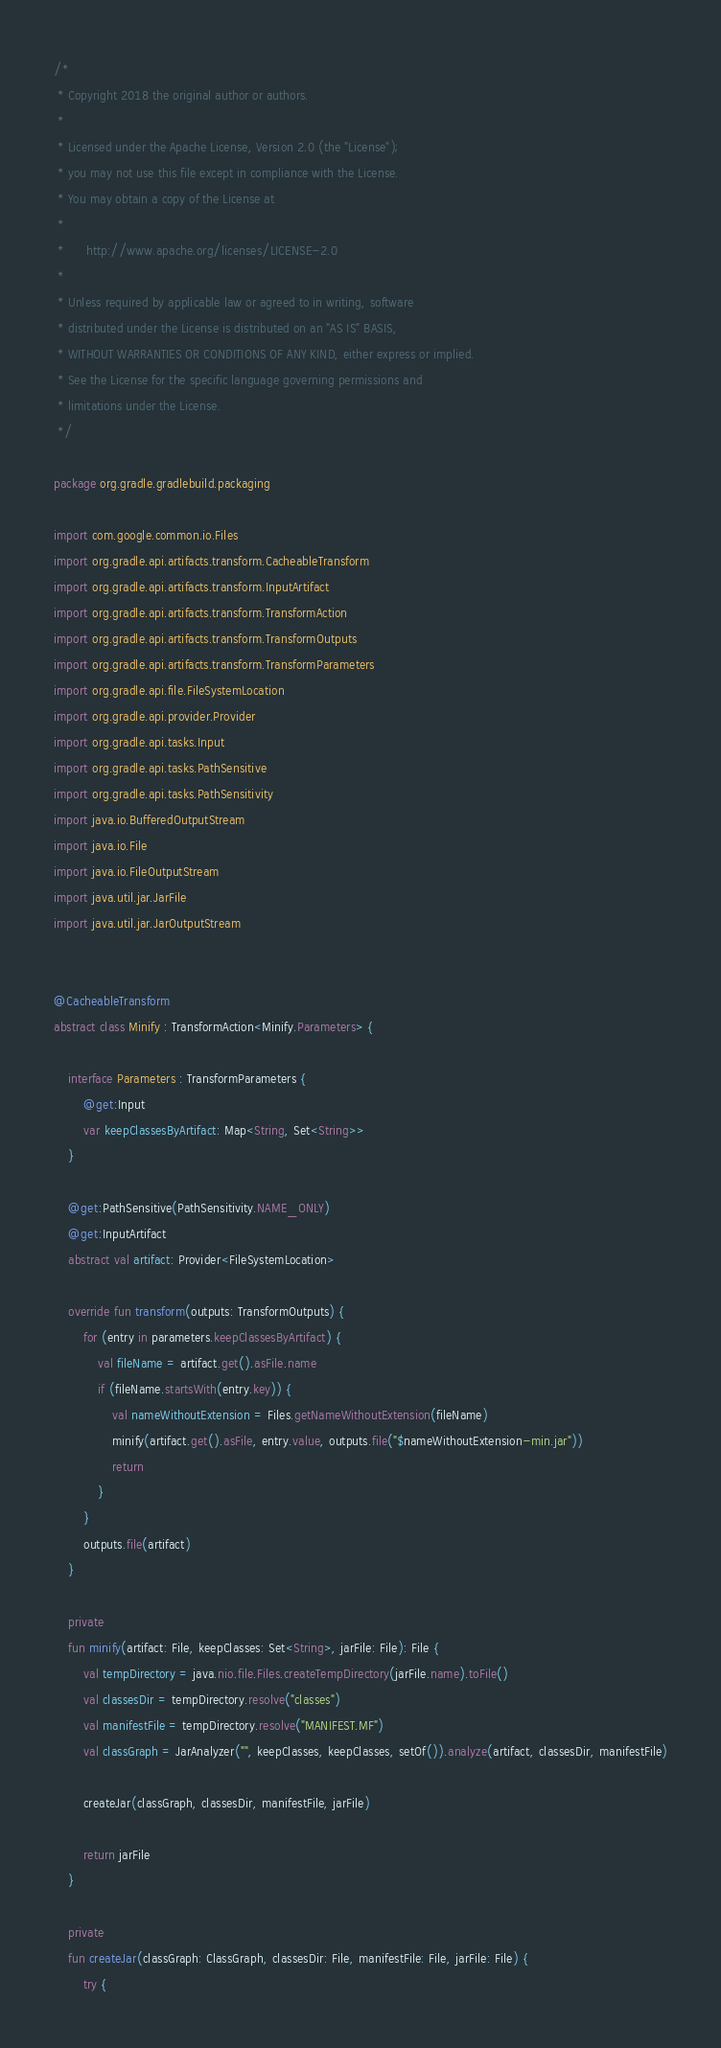Convert code to text. <code><loc_0><loc_0><loc_500><loc_500><_Kotlin_>/*
 * Copyright 2018 the original author or authors.
 *
 * Licensed under the Apache License, Version 2.0 (the "License");
 * you may not use this file except in compliance with the License.
 * You may obtain a copy of the License at
 *
 *      http://www.apache.org/licenses/LICENSE-2.0
 *
 * Unless required by applicable law or agreed to in writing, software
 * distributed under the License is distributed on an "AS IS" BASIS,
 * WITHOUT WARRANTIES OR CONDITIONS OF ANY KIND, either express or implied.
 * See the License for the specific language governing permissions and
 * limitations under the License.
 */

package org.gradle.gradlebuild.packaging

import com.google.common.io.Files
import org.gradle.api.artifacts.transform.CacheableTransform
import org.gradle.api.artifacts.transform.InputArtifact
import org.gradle.api.artifacts.transform.TransformAction
import org.gradle.api.artifacts.transform.TransformOutputs
import org.gradle.api.artifacts.transform.TransformParameters
import org.gradle.api.file.FileSystemLocation
import org.gradle.api.provider.Provider
import org.gradle.api.tasks.Input
import org.gradle.api.tasks.PathSensitive
import org.gradle.api.tasks.PathSensitivity
import java.io.BufferedOutputStream
import java.io.File
import java.io.FileOutputStream
import java.util.jar.JarFile
import java.util.jar.JarOutputStream


@CacheableTransform
abstract class Minify : TransformAction<Minify.Parameters> {

    interface Parameters : TransformParameters {
        @get:Input
        var keepClassesByArtifact: Map<String, Set<String>>
    }

    @get:PathSensitive(PathSensitivity.NAME_ONLY)
    @get:InputArtifact
    abstract val artifact: Provider<FileSystemLocation>

    override fun transform(outputs: TransformOutputs) {
        for (entry in parameters.keepClassesByArtifact) {
            val fileName = artifact.get().asFile.name
            if (fileName.startsWith(entry.key)) {
                val nameWithoutExtension = Files.getNameWithoutExtension(fileName)
                minify(artifact.get().asFile, entry.value, outputs.file("$nameWithoutExtension-min.jar"))
                return
            }
        }
        outputs.file(artifact)
    }

    private
    fun minify(artifact: File, keepClasses: Set<String>, jarFile: File): File {
        val tempDirectory = java.nio.file.Files.createTempDirectory(jarFile.name).toFile()
        val classesDir = tempDirectory.resolve("classes")
        val manifestFile = tempDirectory.resolve("MANIFEST.MF")
        val classGraph = JarAnalyzer("", keepClasses, keepClasses, setOf()).analyze(artifact, classesDir, manifestFile)

        createJar(classGraph, classesDir, manifestFile, jarFile)

        return jarFile
    }

    private
    fun createJar(classGraph: ClassGraph, classesDir: File, manifestFile: File, jarFile: File) {
        try {</code> 